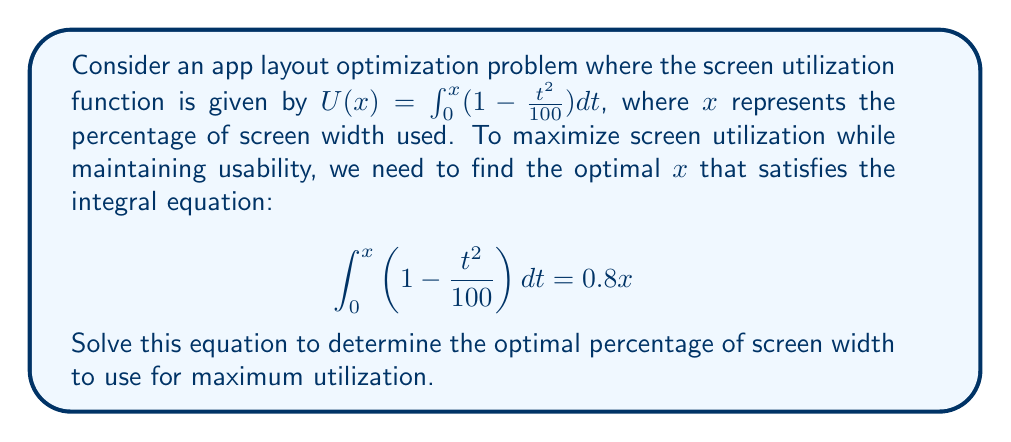Teach me how to tackle this problem. Let's approach this step-by-step:

1) First, we need to solve the left side of the equation:
   $$\int_0^x (1 - \frac{t^2}{100})dt = [t - \frac{t^3}{300}]_0^x = x - \frac{x^3}{300}$$

2) Now our equation becomes:
   $$x - \frac{x^3}{300} = 0.8x$$

3) Rearranging the terms:
   $$x - \frac{x^3}{300} - 0.8x = 0$$
   $$0.2x - \frac{x^3}{300} = 0$$

4) Multiplying both sides by 300:
   $$60x - x^3 = 0$$

5) Factoring out x:
   $$x(60 - x^2) = 0$$

6) Solving this equation:
   Either $x = 0$ (which is not useful for our problem), or:
   $$60 - x^2 = 0$$
   $$x^2 = 60$$
   $$x = \sqrt{60} \approx 7.746$$

7) Since x represents a percentage, we multiply by 100:
   Optimal percentage ≈ 77.46%

This solution maximizes screen utilization while maintaining the constraint for usability.
Answer: 77.46% 